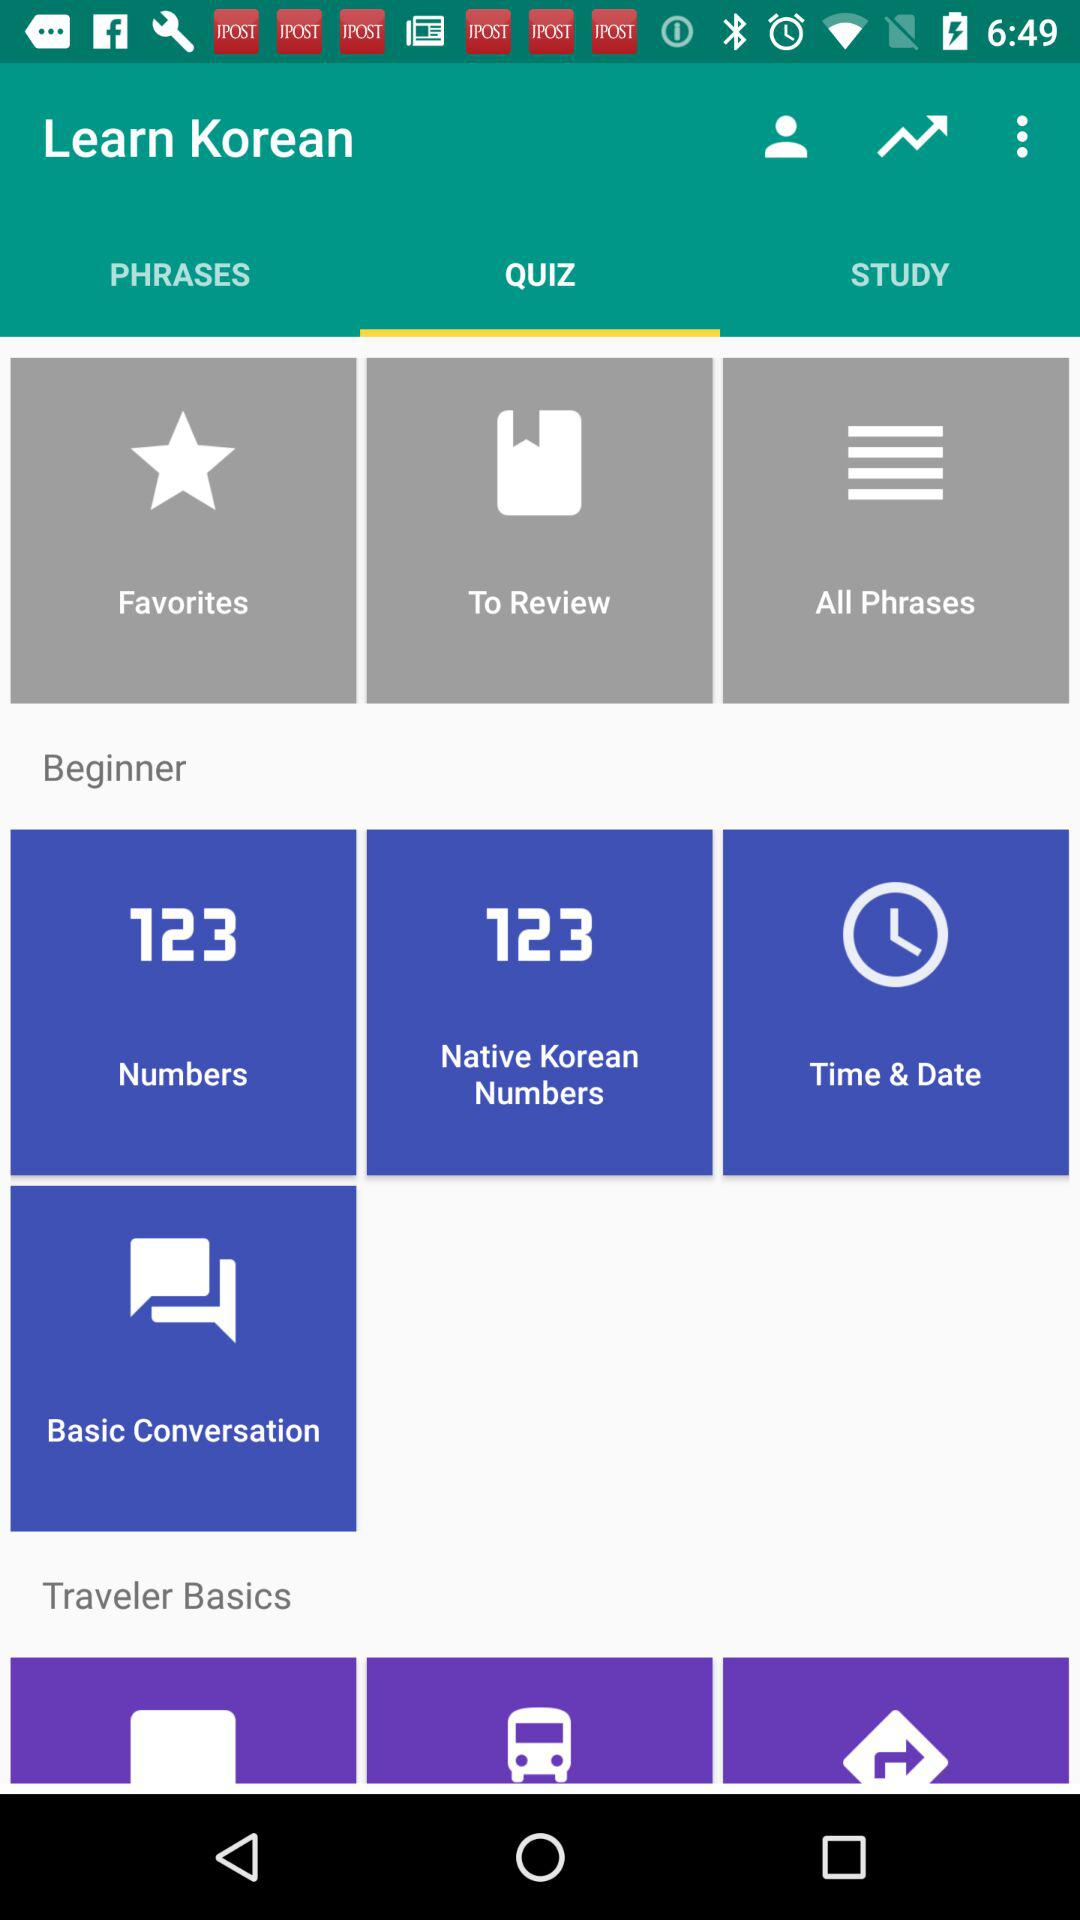What is the application name? The application name is "Learn Korean". 